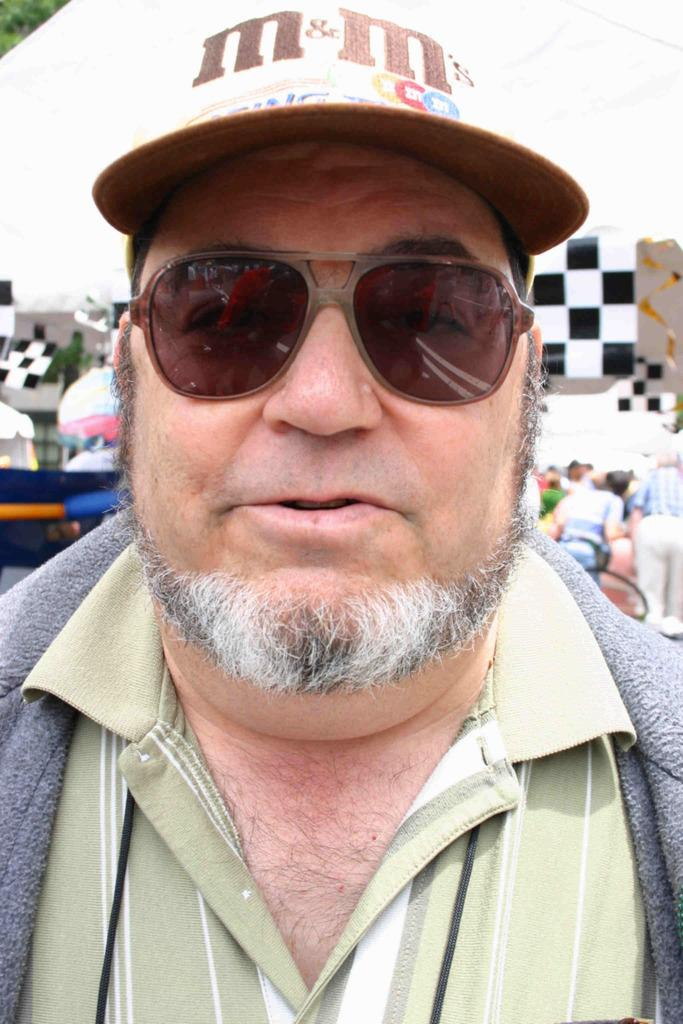What is the person in the image wearing on their face? The person in the image is wearing goggles. What else is the person wearing in the image? The person is also wearing a cap. What can be seen in the background of the image? There are people and objects in the background of the image. What type of juice is the person drinking in the image? There is no juice present in the image; the person is wearing goggles and a cap. Who created the bath that the person is sitting in within the image? There is no bath present in the image, and therefore no need for a creator. 